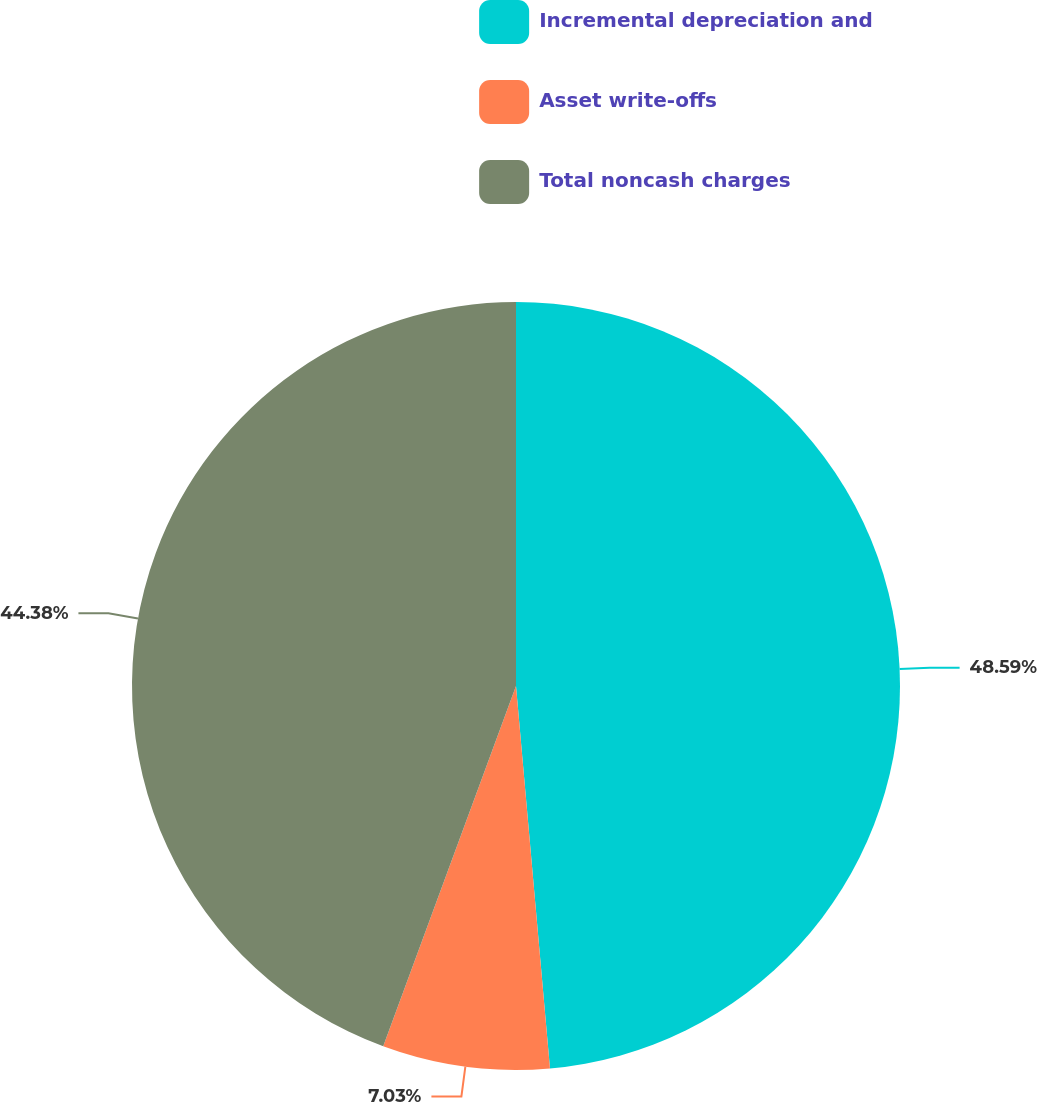Convert chart to OTSL. <chart><loc_0><loc_0><loc_500><loc_500><pie_chart><fcel>Incremental depreciation and<fcel>Asset write-offs<fcel>Total noncash charges<nl><fcel>48.59%<fcel>7.03%<fcel>44.38%<nl></chart> 